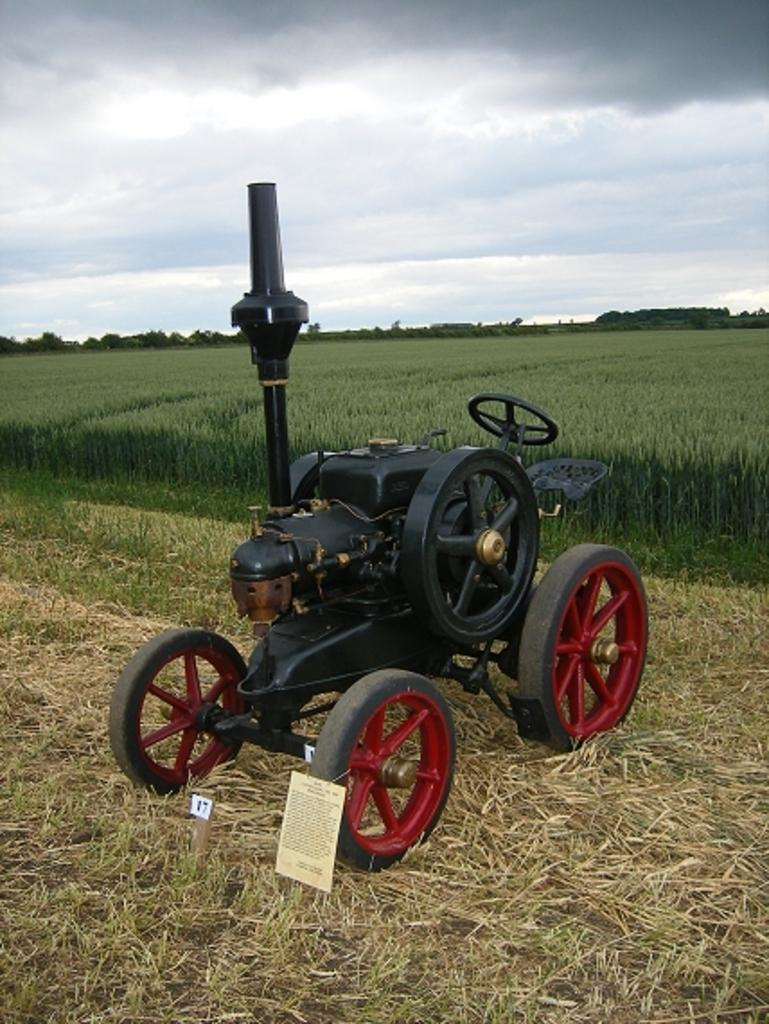What is the main subject in the image? There is a vehicle in the image. What type of vegetation can be seen in the image? There is dry grass, grass, a plant, and trees in the image. What is the condition of the sky in the image? The sky is cloudy in the image. What type of calculator can be seen on the vehicle in the image? There is no calculator present on the vehicle in the image. How many bananas are hanging from the trees in the image? There are no bananas visible in the image; only trees are present. 